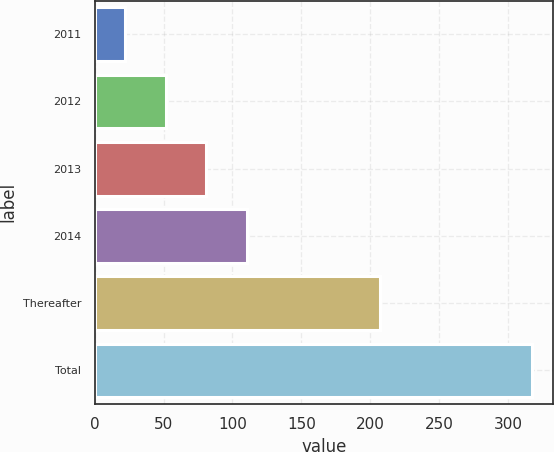Convert chart. <chart><loc_0><loc_0><loc_500><loc_500><bar_chart><fcel>2011<fcel>2012<fcel>2013<fcel>2014<fcel>Thereafter<fcel>Total<nl><fcel>22<fcel>51.5<fcel>81<fcel>110.5<fcel>207<fcel>317<nl></chart> 